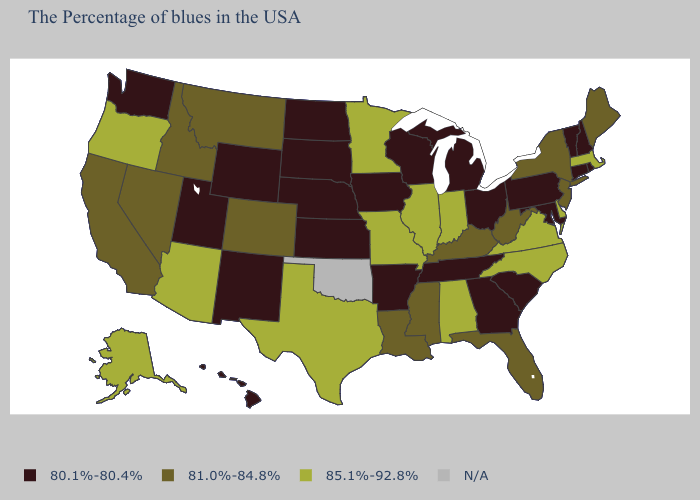Among the states that border Wyoming , which have the highest value?
Short answer required. Colorado, Montana, Idaho. Name the states that have a value in the range N/A?
Quick response, please. Oklahoma. Name the states that have a value in the range 80.1%-80.4%?
Write a very short answer. Rhode Island, New Hampshire, Vermont, Connecticut, Maryland, Pennsylvania, South Carolina, Ohio, Georgia, Michigan, Tennessee, Wisconsin, Arkansas, Iowa, Kansas, Nebraska, South Dakota, North Dakota, Wyoming, New Mexico, Utah, Washington, Hawaii. Is the legend a continuous bar?
Give a very brief answer. No. Which states have the highest value in the USA?
Be succinct. Massachusetts, Delaware, Virginia, North Carolina, Indiana, Alabama, Illinois, Missouri, Minnesota, Texas, Arizona, Oregon, Alaska. Is the legend a continuous bar?
Write a very short answer. No. Does Idaho have the highest value in the West?
Be succinct. No. What is the lowest value in the West?
Be succinct. 80.1%-80.4%. Does the first symbol in the legend represent the smallest category?
Concise answer only. Yes. What is the highest value in the Northeast ?
Short answer required. 85.1%-92.8%. Does Maryland have the lowest value in the USA?
Quick response, please. Yes. Name the states that have a value in the range 85.1%-92.8%?
Write a very short answer. Massachusetts, Delaware, Virginia, North Carolina, Indiana, Alabama, Illinois, Missouri, Minnesota, Texas, Arizona, Oregon, Alaska. Name the states that have a value in the range N/A?
Quick response, please. Oklahoma. What is the highest value in the USA?
Keep it brief. 85.1%-92.8%. 